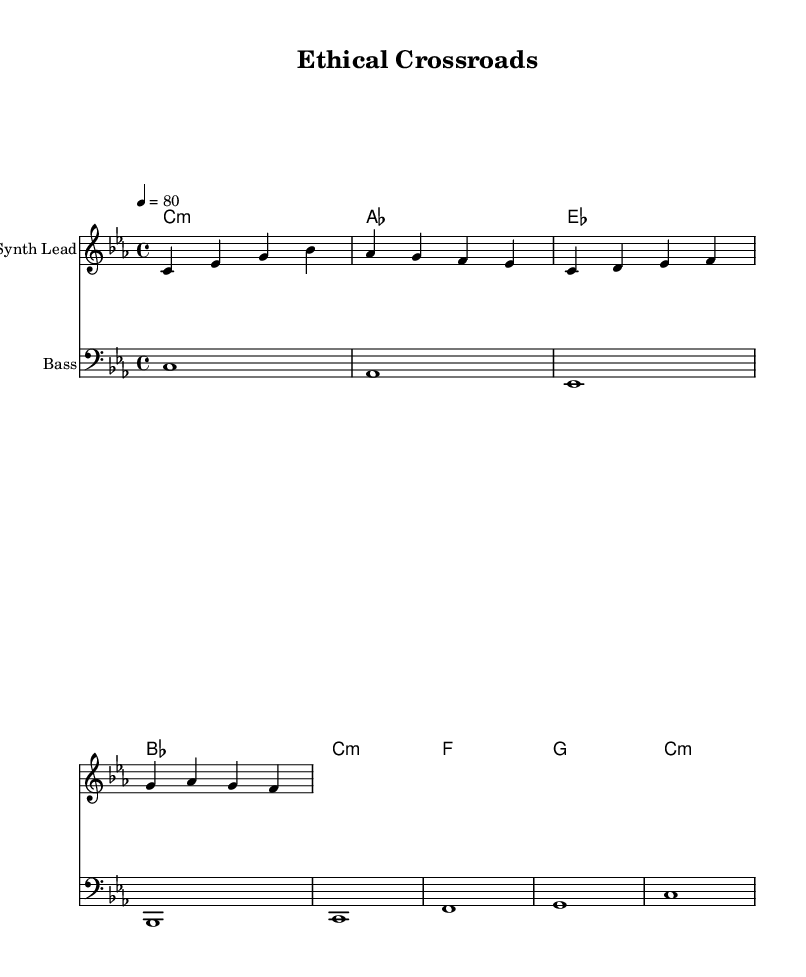What is the key signature of this music? The key signature is C minor, which has three flats (B♭, E♭, A♭) as indicated in the key signature at the beginning of the staff.
Answer: C minor What is the time signature of this music? The time signature is indicated at the beginning of the score as 4/4, meaning there are four beats per measure and the quarter note gets one beat.
Answer: 4/4 What is the tempo marking of this piece? The tempo marking indicates a speed of 80 beats per minute, as seen in the tempo instruction ("4 = 80") at the start of the global section.
Answer: 80 How many measures does the melody contain? The melody contains a total of four measures, which can be counted visually from the melody section as it progresses through four groups of notes.
Answer: 4 What type of electronic music does this piece represent? The piece represents downtempo electronic music, characterized by slower beats and a relaxed atmosphere, as inferred from the title "Ethical Crossroads" and its musical elements.
Answer: Downtempo electronic Which instruments are featured in the score? The score features two instruments: a Synth Lead for the melody and Bass for the harmonic foundation, as indicated in the staff labels.
Answer: Synth Lead and Bass What is the harmonic structure of the piece? The harmonic structure consists of minor chords, specifically using C minor, A♭ major, E♭ major, and B♭ major, as denoted in the chord mode section under harmonies.
Answer: C minor, A♭ major, E♭ major, B♭ major 